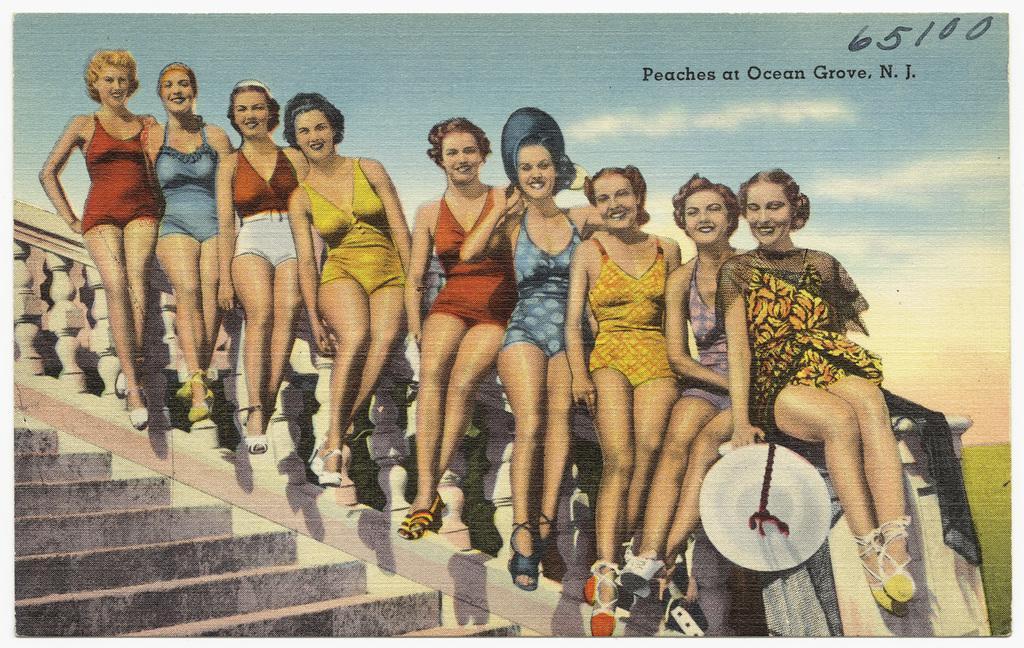Can you describe this image briefly? In this picture I can observe women sitting on the railing. On the top right side I can observe some text. In the background there are some clouds in the sky. 